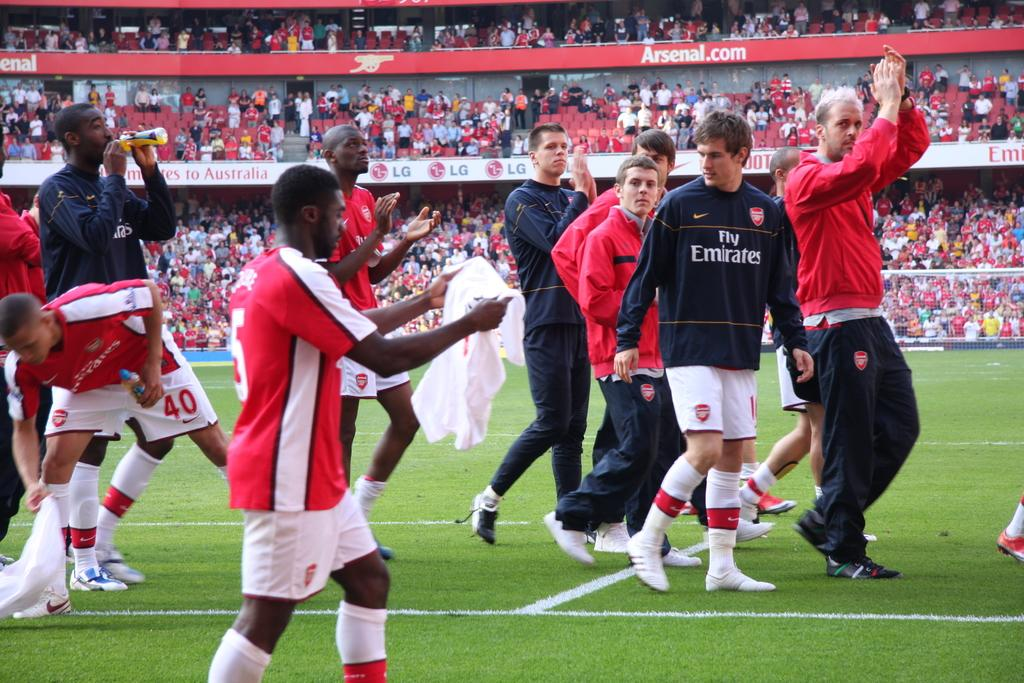What is happening in the image involving the group of people? There is a group of players in the image, and they are walking in a football field. What are the players holding in the image? The players are holding a white t-shirt in the image. Can you describe the setting where the players are walking? The players are walking in a football field, which is a large outdoor area designed for playing football. How many people are present in the image as spectators? There are many audience members sitting in the stadium, which is a structure designed for watching sports events. What type of bread is being served to the mother in the image? There is no mother or bread present in the image; it features a group of players walking in a football field and holding a white t-shirt. 